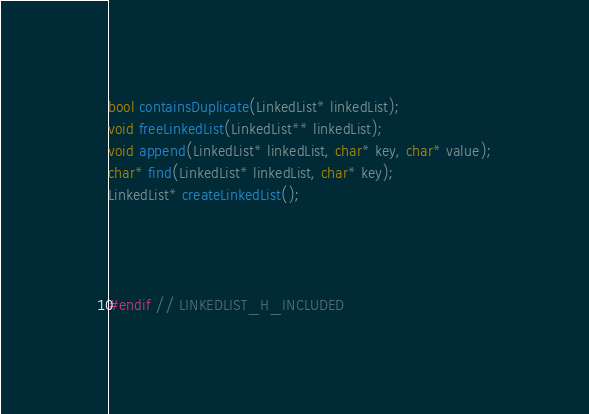<code> <loc_0><loc_0><loc_500><loc_500><_C_>
bool containsDuplicate(LinkedList* linkedList);
void freeLinkedList(LinkedList** linkedList);
void append(LinkedList* linkedList, char* key, char* value);
char* find(LinkedList* linkedList, char* key);
LinkedList* createLinkedList();




#endif // LINKEDLIST_H_INCLUDED
</code> 